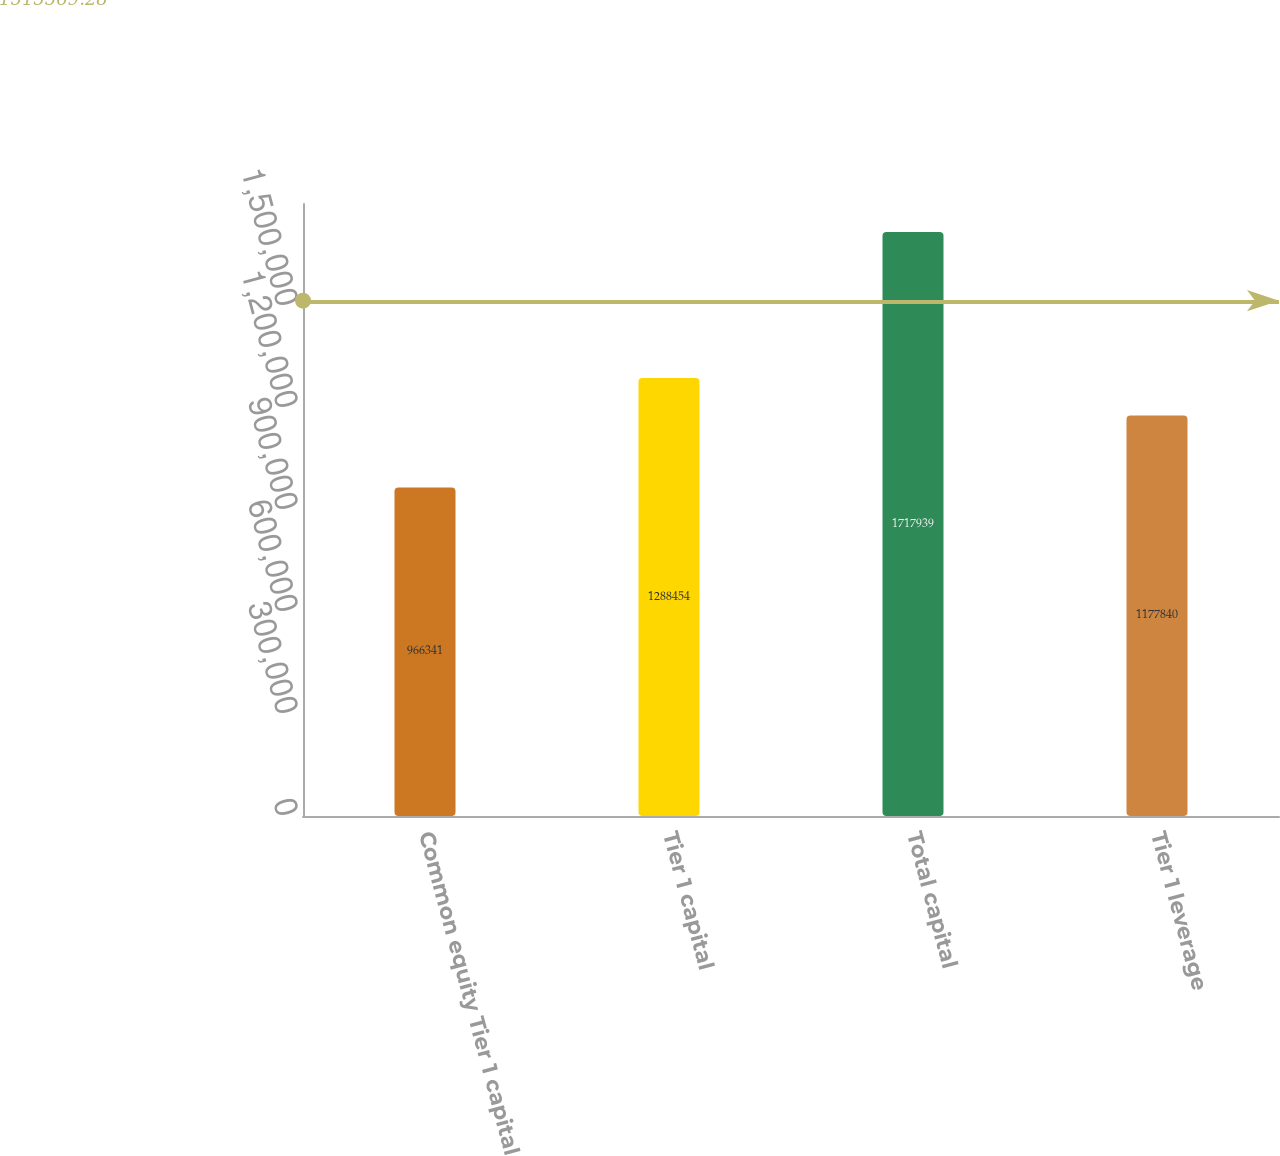Convert chart. <chart><loc_0><loc_0><loc_500><loc_500><bar_chart><fcel>Common equity Tier 1 capital<fcel>Tier 1 capital<fcel>Total capital<fcel>Tier 1 leverage<nl><fcel>966341<fcel>1.28845e+06<fcel>1.71794e+06<fcel>1.17784e+06<nl></chart> 